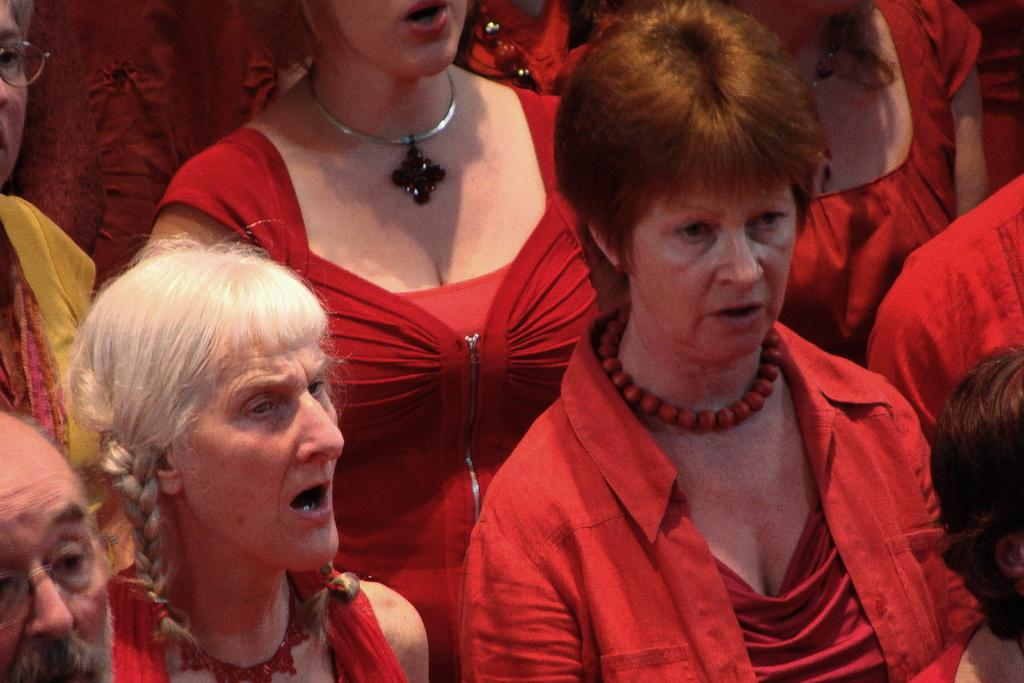How many people are in the image? There is a group of people in the image. What color clothes are the people wearing? The people are wearing red color clothes. Can you describe the setting where the image was taken? The image may have been taken in a hall. What type of doll is sitting on the fifth chair in the image? There is no doll present in the image, and there is no mention of chairs or a fifth chair. 